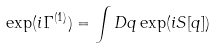Convert formula to latex. <formula><loc_0><loc_0><loc_500><loc_500>\exp ( i \Gamma ^ { ( 1 ) } ) = \int D q \exp ( i S [ q ] )</formula> 